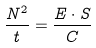<formula> <loc_0><loc_0><loc_500><loc_500>\frac { N ^ { 2 } } { t } = \frac { E \cdot S } { C }</formula> 